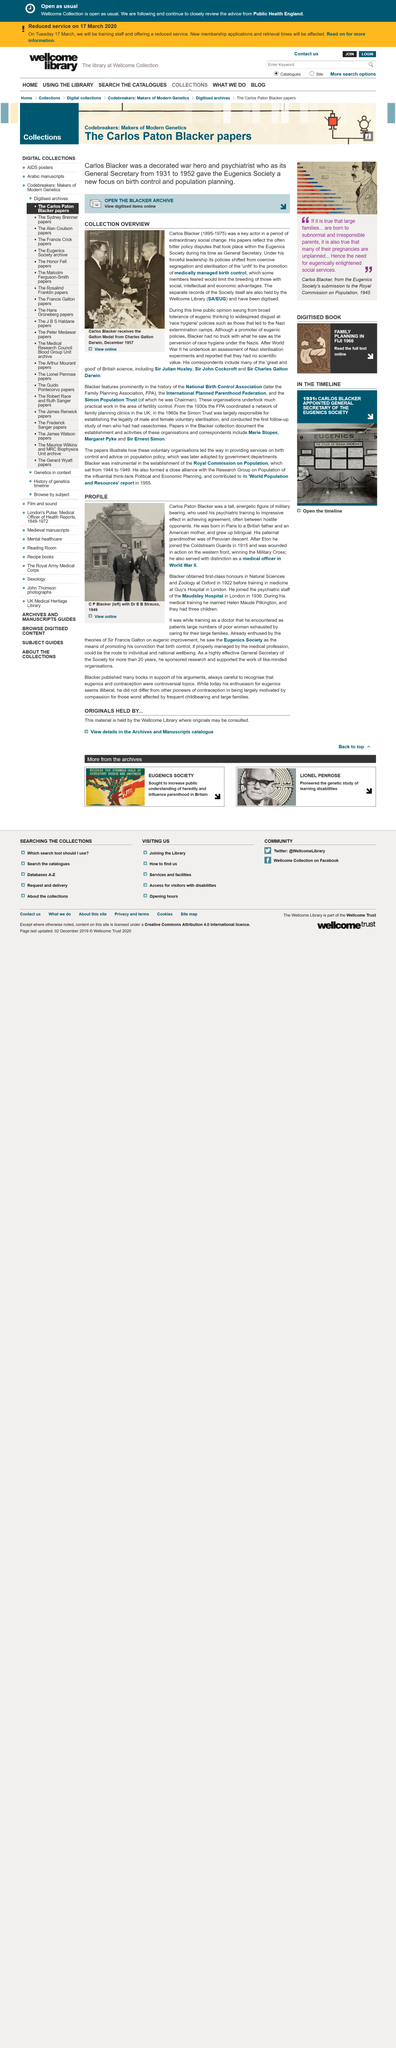Outline some significant characteristics in this image. Carlos Blacker reached the age of 80, having attained this milestone in his life. Carlos Paton Blacker, a trained psychiatrist, was successful in achieving agreement between hostile opponents through his impressive use of his training. The text is discussing the eugenics society and its practices. The text is discussing someone named Carlos Blacker. Carlos Paton Blacker served with distinction as a medical officer in World War II. 